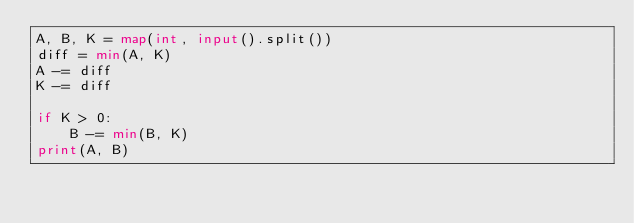<code> <loc_0><loc_0><loc_500><loc_500><_Python_>A, B, K = map(int, input().split())
diff = min(A, K)
A -= diff
K -= diff

if K > 0:
    B -= min(B, K)
print(A, B)
</code> 